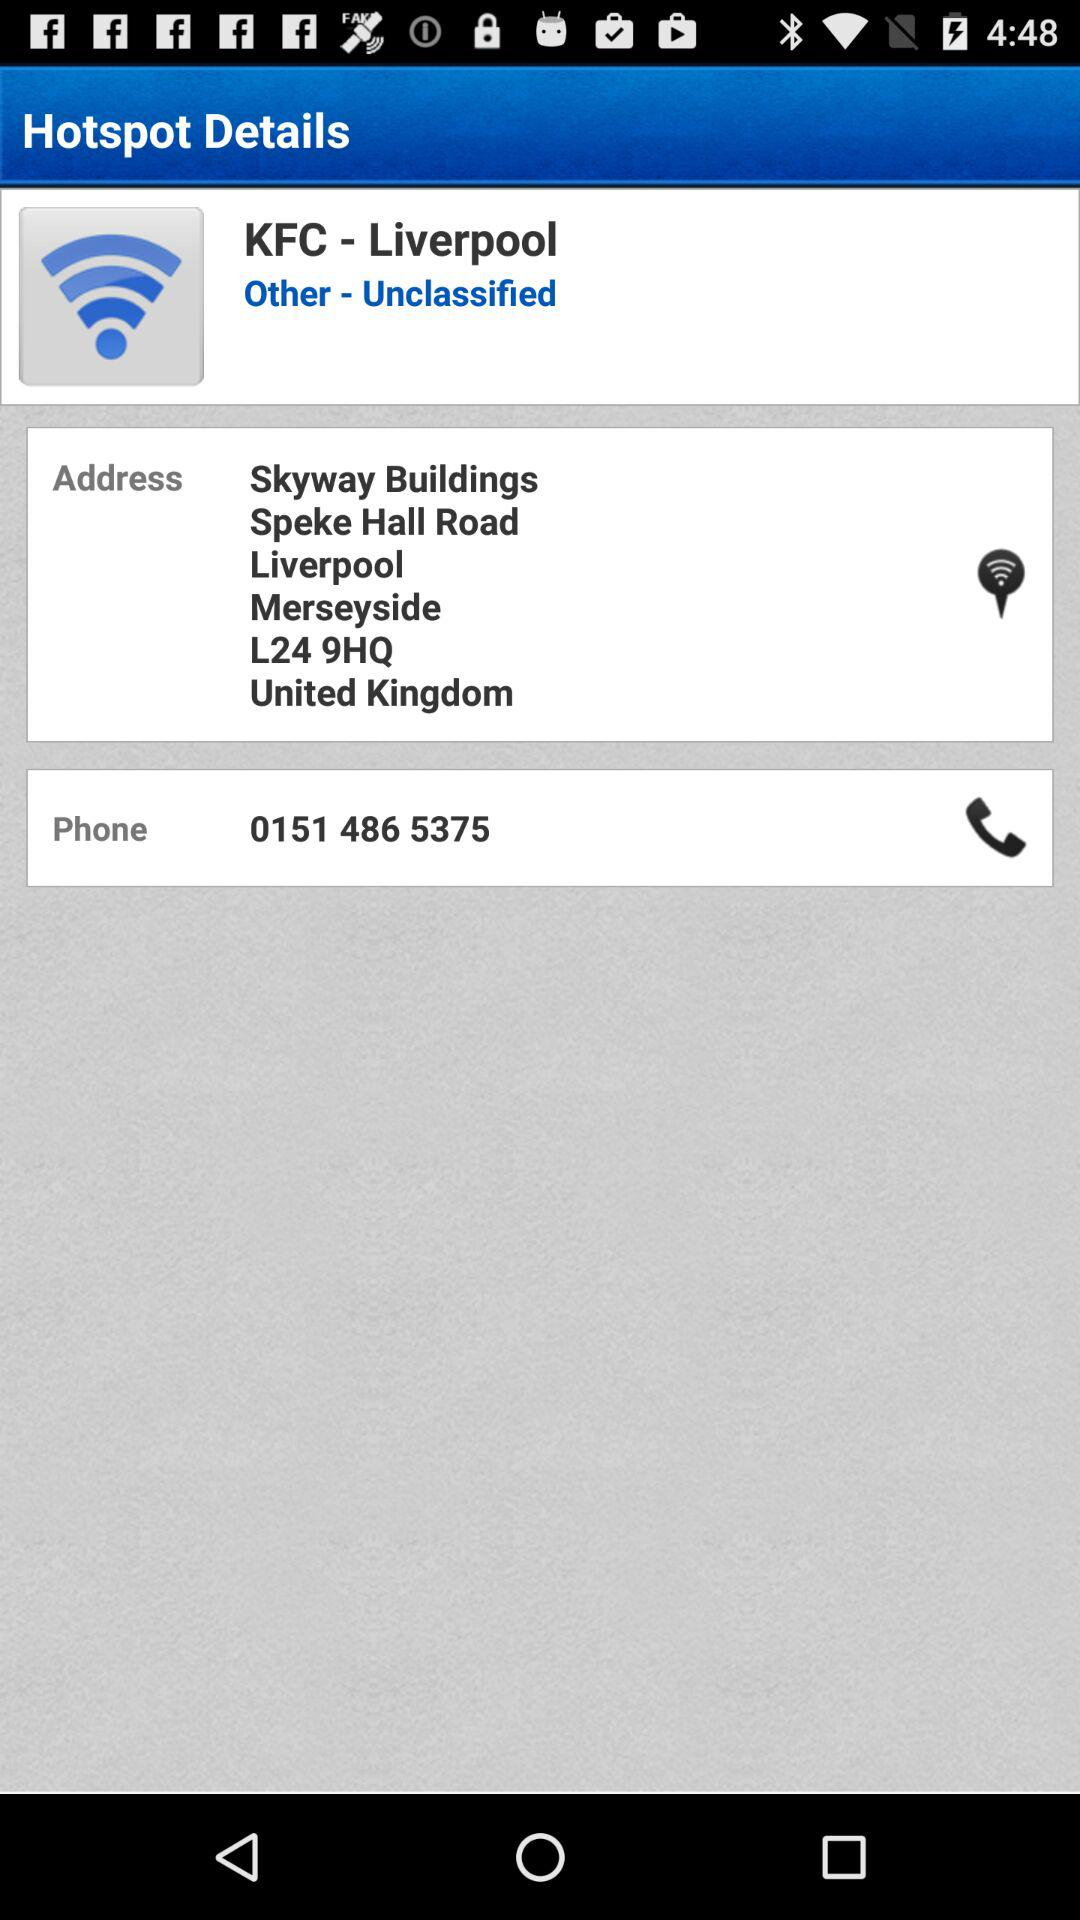What is the phone number? The phone number is 0151 486 5375. 